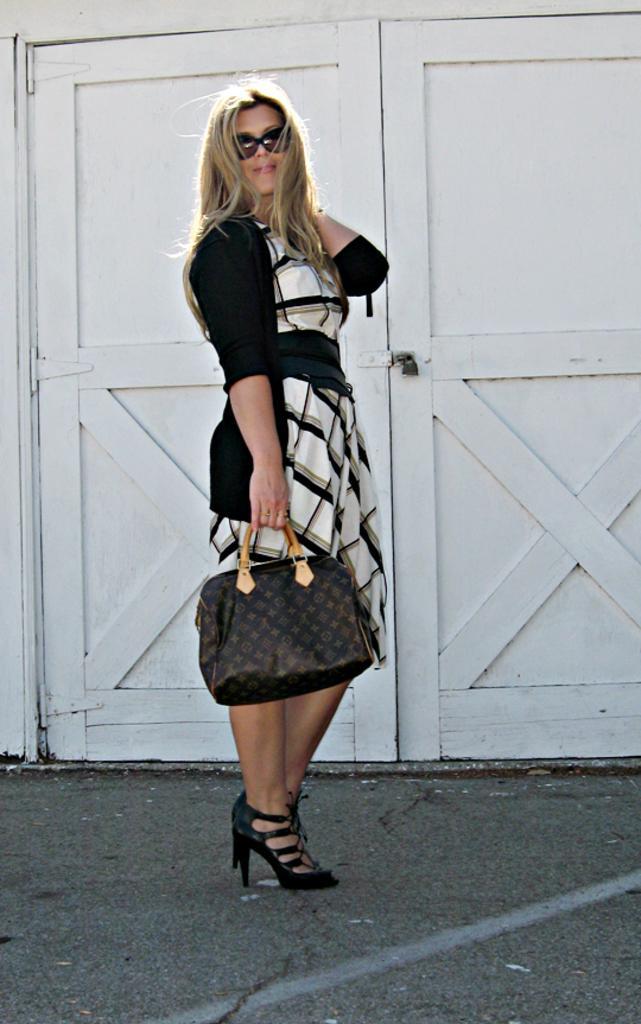Describe this image in one or two sentences. In this picture we can see women wore jacket, goggle carrying bag in one hand and in background we can see door. 